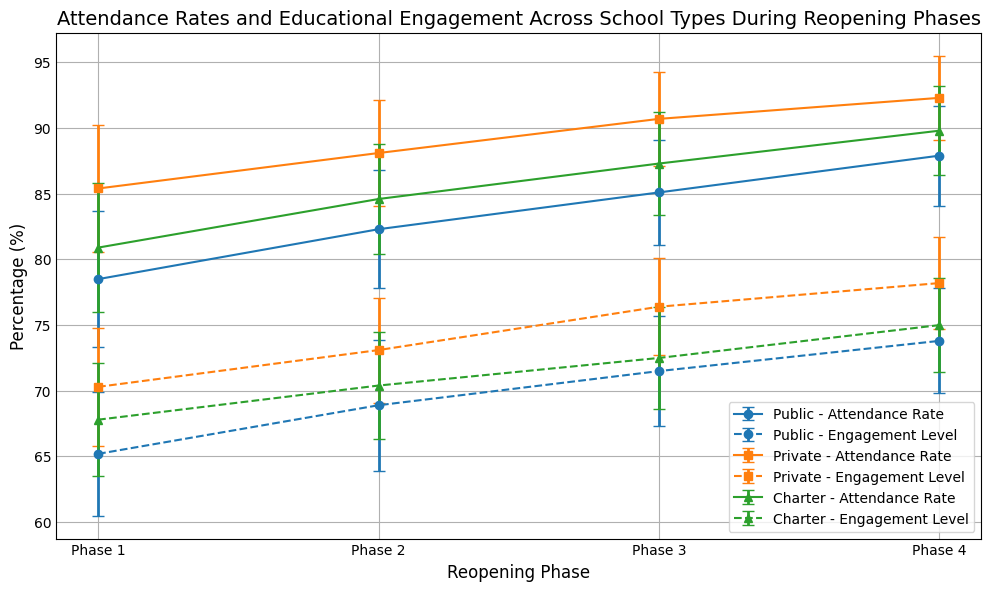What is the range of attendance rates for public schools across all reopening phases? To find the range, find the difference between the highest and lowest mean attendance rates for public schools. From the data, the rates are Phase 1: 78.5%, Phase 2: 82.3%, Phase 3: 85.1%, Phase 4: 87.9%. The range is 87.9% - 78.5% = 9.4%.
Answer: 9.4% Which school type had the highest mean engagement level in Phase 3? Compare the mean engagement levels for all school types during Phase 3. Public: 71.5%, Private: 76.4%, Charter: 72.5%. The Private schools had the highest mean engagement level at 76.4%.
Answer: Private Is the mean attendance rate in Phase 2 higher for Public or Charter schools? Compare the mean attendance rates for Public and Charter schools in Phase 2. Public: 82.3%, Charter: 84.6%. Charter schools have a higher mean attendance rate in Phase 2.
Answer: Charter Which school type shows the smallest variability in engagement level across all reopening phases? Examine the standard deviations of engagement levels. Public: std devs are 4.7, 5.0, 4.2, 4.0. Private: std devs are 4.5, 4.0, 3.7, 3.5. Charter: std devs are 4.3, 4.1, 3.9, 3.6. Private schools have the smallest variabilities.
Answer: Private In which reopening phase did the engagement level for Charter schools show the largest improvement compared to the previous phase? Compare the mean engagement levels for Charter schools between successive phases. Phase 1: 67.8%, Phase 2: 70.4%, Phase 3: 72.5%, Phase 4: 75.0%. The largest improvement is from Phase 1 to Phase 2 (70.4 - 67.8 = 2.6%).
Answer: Phase 2 What is the mean attendance rate difference between private and public schools in Phase 4? Find mean attendance rates for Public (87.9%) and Private (92.3%) schools in Phase 4, then calculate the difference: 92.3% - 87.9% = 4.4%.
Answer: 4.4% What trend do you observe in the mean engagement levels of Public schools across the phases? Examine the engagement levels for Public schools. The values are 65.2%, 68.9%, 71.5%, 73.8%. There's a steady increase in engagement levels from Phase 1 to Phase 4.
Answer: Increasing trend Which school type had the largest standard deviation in attendance rates during any phase? Identify the highest standard deviation in the attendance rates across all phases and school types. Public: 5.2% (Phase 1), Private: 4.8% (Phase 1), Charter: 4.9% (Phase 1). Public schools during Phase 1 had the largest standard deviation.
Answer: Public 